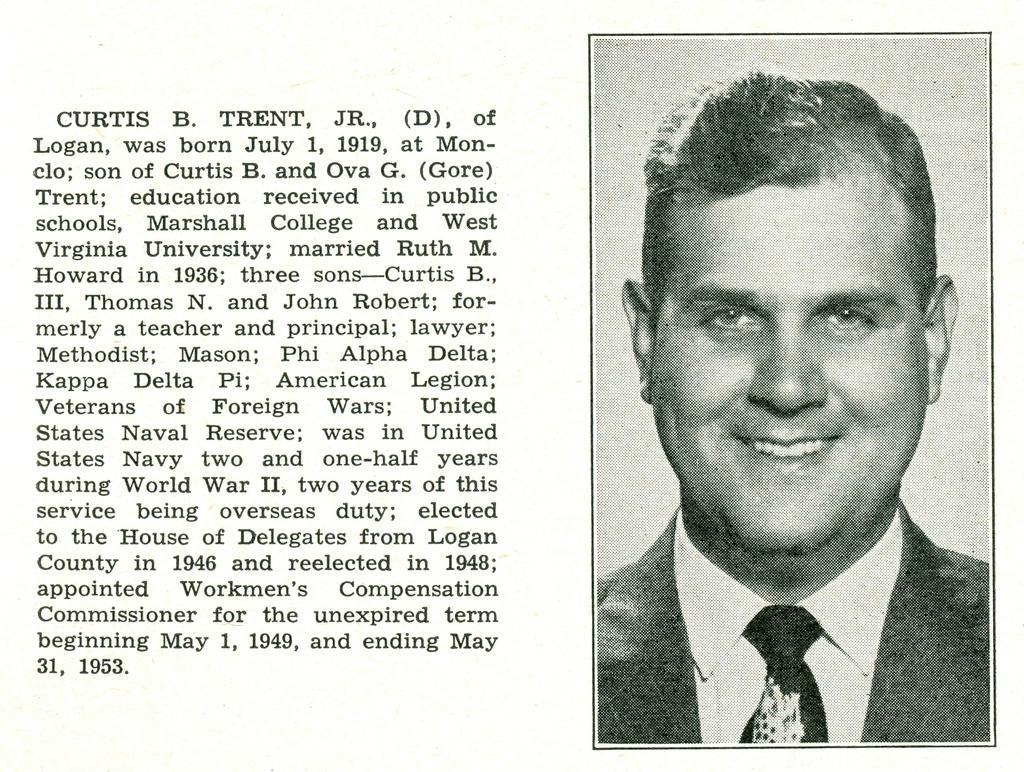Please provide a concise description of this image. In the foreground of this image, there is a black and white poster of a man and some text on the left side of the image. 